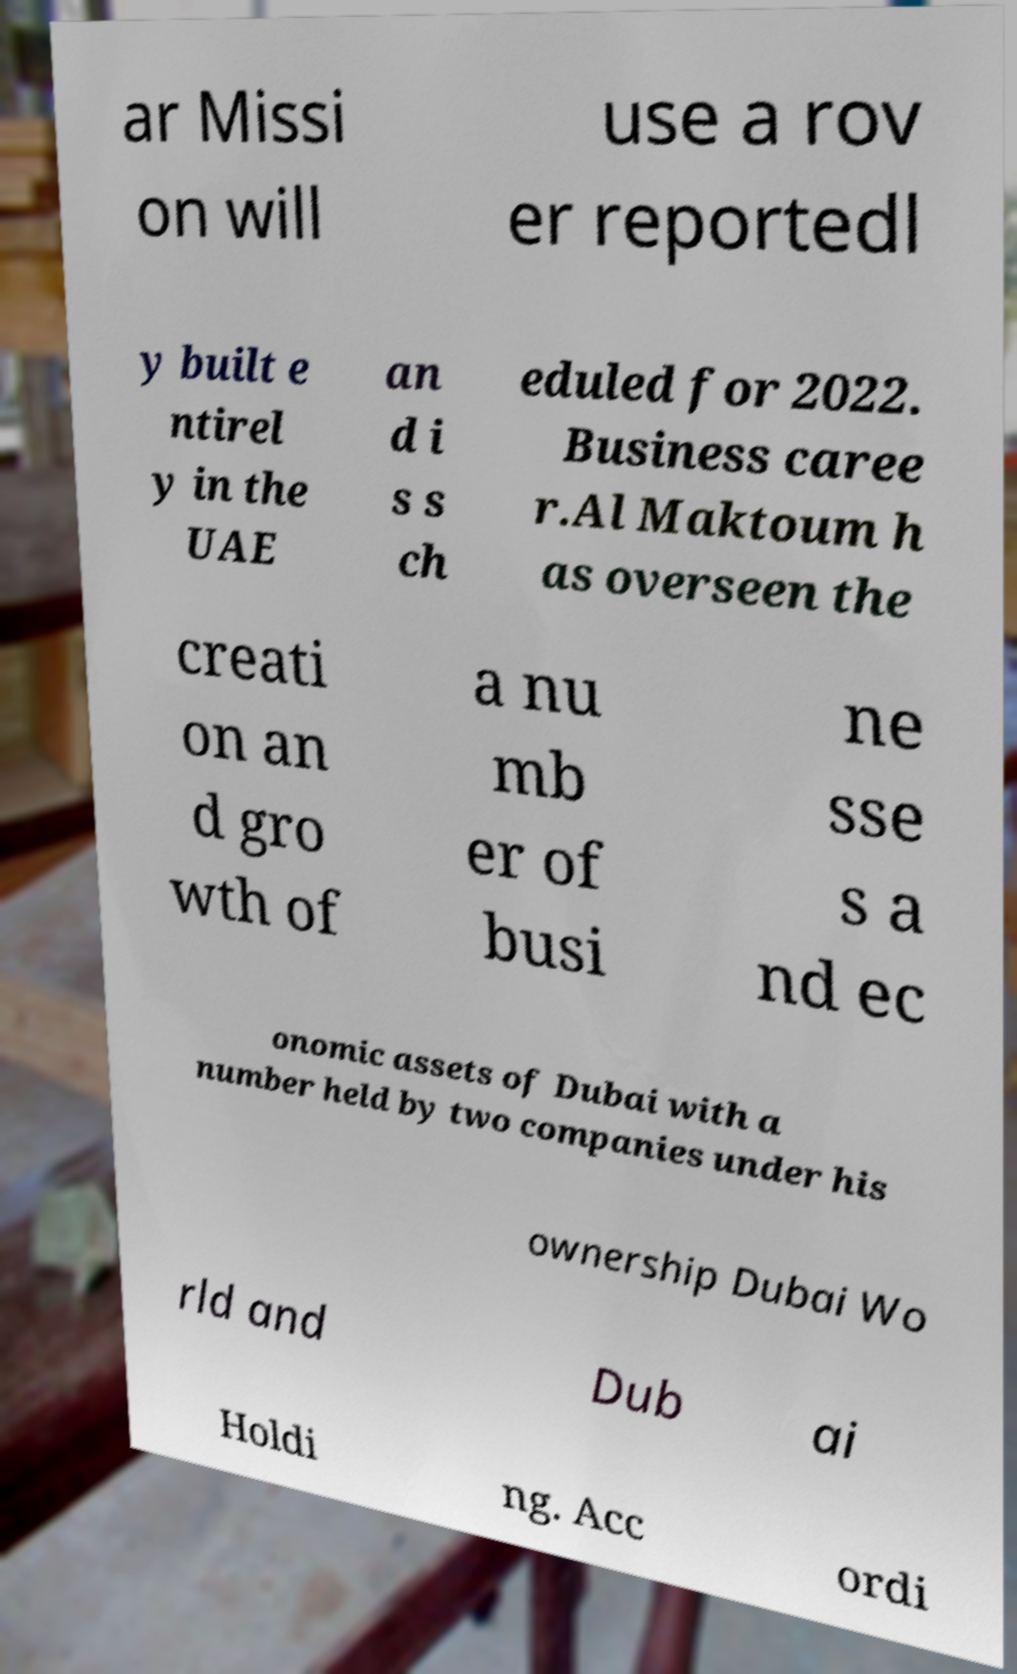Please read and relay the text visible in this image. What does it say? ar Missi on will use a rov er reportedl y built e ntirel y in the UAE an d i s s ch eduled for 2022. Business caree r.Al Maktoum h as overseen the creati on an d gro wth of a nu mb er of busi ne sse s a nd ec onomic assets of Dubai with a number held by two companies under his ownership Dubai Wo rld and Dub ai Holdi ng. Acc ordi 